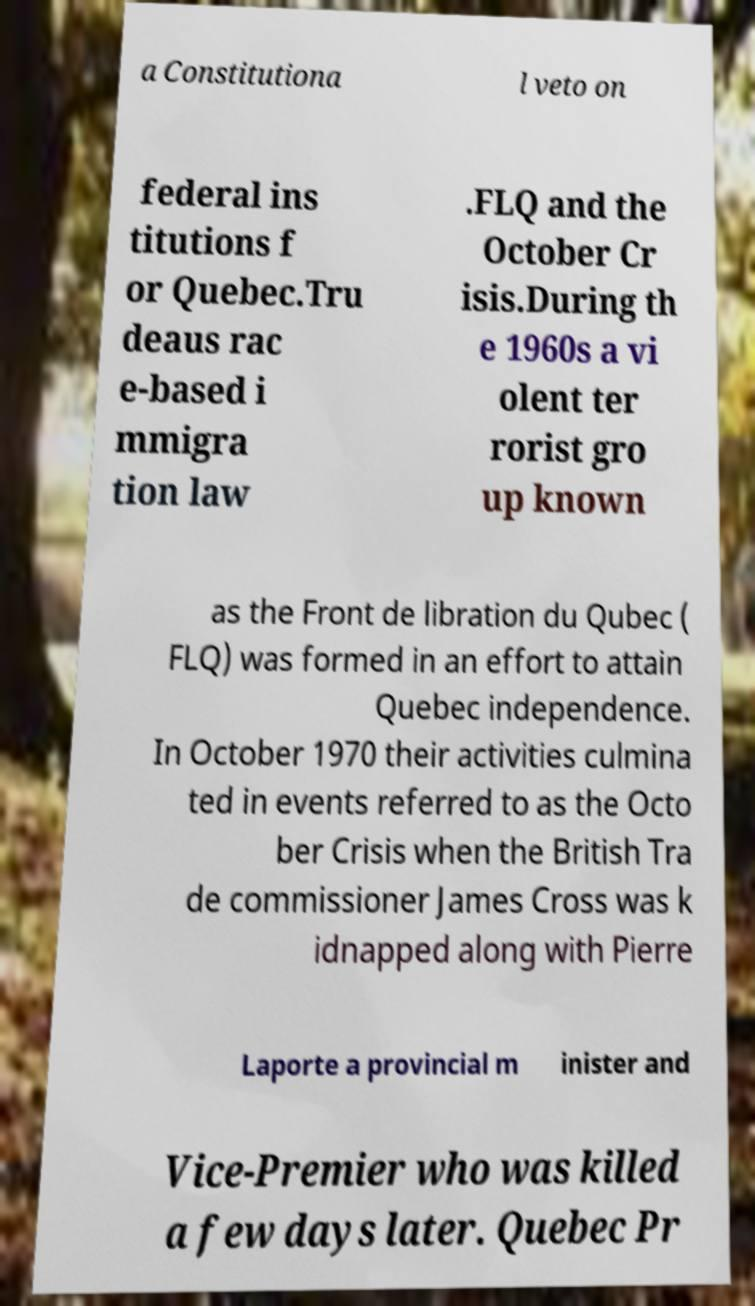Can you read and provide the text displayed in the image?This photo seems to have some interesting text. Can you extract and type it out for me? a Constitutiona l veto on federal ins titutions f or Quebec.Tru deaus rac e-based i mmigra tion law .FLQ and the October Cr isis.During th e 1960s a vi olent ter rorist gro up known as the Front de libration du Qubec ( FLQ) was formed in an effort to attain Quebec independence. In October 1970 their activities culmina ted in events referred to as the Octo ber Crisis when the British Tra de commissioner James Cross was k idnapped along with Pierre Laporte a provincial m inister and Vice-Premier who was killed a few days later. Quebec Pr 